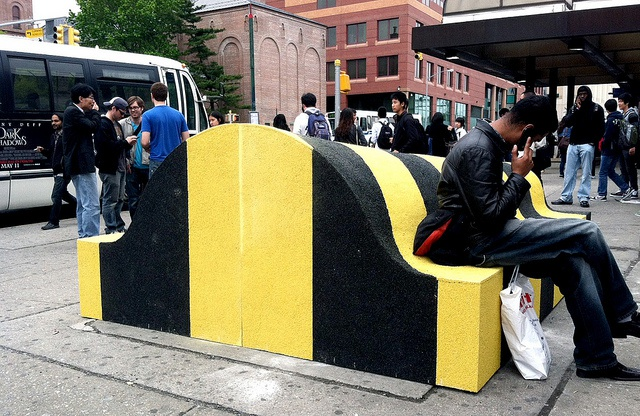Describe the objects in this image and their specific colors. I can see bench in darkgray, black, khaki, and gray tones, bench in darkgray, khaki, black, and lightyellow tones, people in darkgray, black, and gray tones, bus in darkgray, black, white, and gray tones, and people in darkgray, black, gray, and blue tones in this image. 